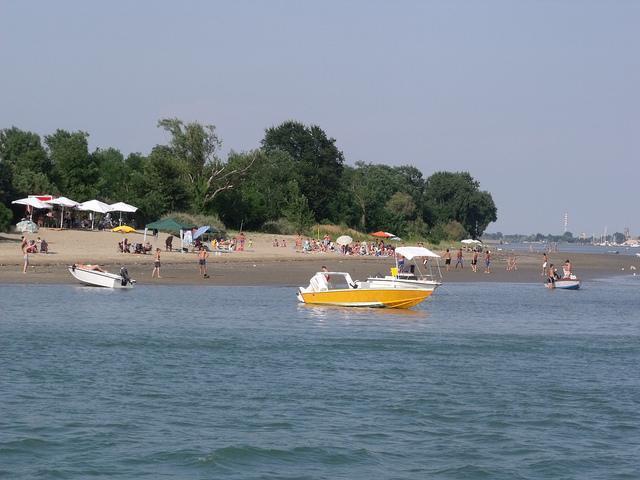What energy moves these boats?
Make your selection from the four choices given to correctly answer the question.
Options: Manual force, diesel, electricity, gas. Electricity. 